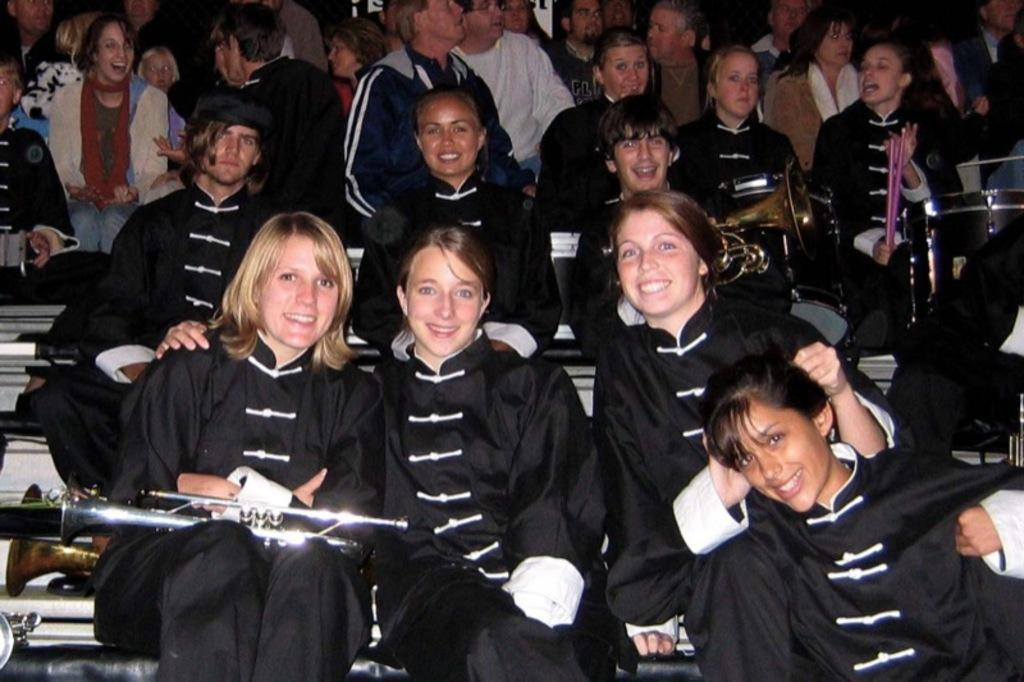What are the people in the image doing? The people in the image are sitting. What are the people wearing? The people are wearing black uniforms. What else can be seen in the image besides the people? There are musical instruments in the image. Can you describe the background of the image? There are other people visible in the background of the image. How does the quarter affect the people's breathing in the image? There is no mention of a quarter or any breathing issues in the image. The image only shows people sitting and wearing black uniforms, with musical instruments present. 